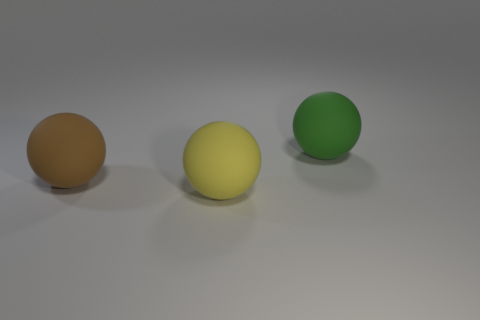Subtract all big yellow balls. How many balls are left? 2 Subtract 0 gray balls. How many objects are left? 3 Subtract 1 spheres. How many spheres are left? 2 Subtract all green spheres. Subtract all cyan blocks. How many spheres are left? 2 Subtract all purple cylinders. How many gray spheres are left? 0 Subtract all large blue metal balls. Subtract all big rubber things. How many objects are left? 0 Add 2 large green things. How many large green things are left? 3 Add 1 rubber spheres. How many rubber spheres exist? 4 Add 2 tiny blue shiny objects. How many objects exist? 5 Subtract all brown spheres. How many spheres are left? 2 